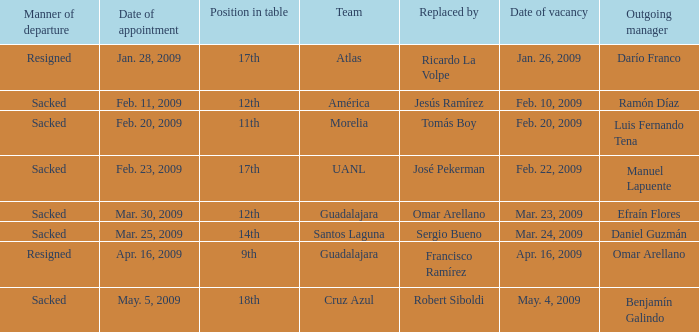What is Team, when Replaced By is "Omar Arellano"? Guadalajara. 